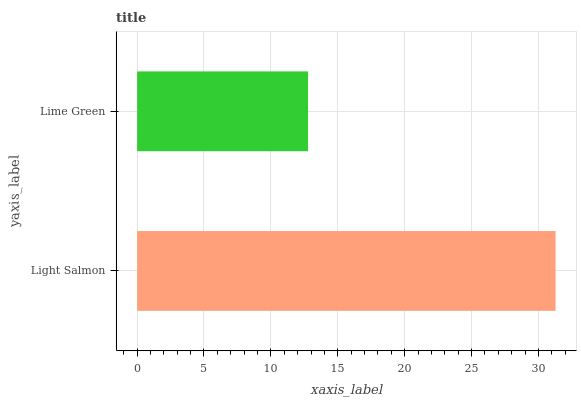Is Lime Green the minimum?
Answer yes or no. Yes. Is Light Salmon the maximum?
Answer yes or no. Yes. Is Lime Green the maximum?
Answer yes or no. No. Is Light Salmon greater than Lime Green?
Answer yes or no. Yes. Is Lime Green less than Light Salmon?
Answer yes or no. Yes. Is Lime Green greater than Light Salmon?
Answer yes or no. No. Is Light Salmon less than Lime Green?
Answer yes or no. No. Is Light Salmon the high median?
Answer yes or no. Yes. Is Lime Green the low median?
Answer yes or no. Yes. Is Lime Green the high median?
Answer yes or no. No. Is Light Salmon the low median?
Answer yes or no. No. 